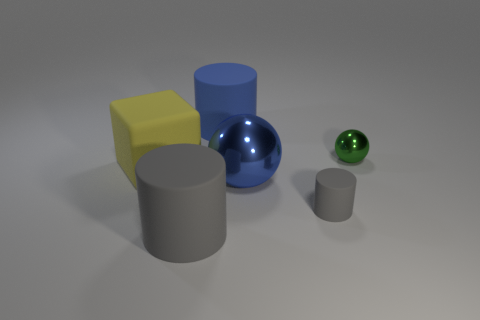There is a gray rubber object behind the big gray matte thing; what is its shape?
Offer a terse response. Cylinder. What number of big gray metal objects are there?
Ensure brevity in your answer.  0. Are the small green object and the blue sphere made of the same material?
Give a very brief answer. Yes. Are there more big blue rubber cylinders that are to the right of the large blue matte object than large yellow rubber cubes?
Your answer should be compact. No. How many objects are either blue spheres or large blue objects behind the big yellow object?
Keep it short and to the point. 2. Are there more blue matte cylinders that are to the left of the large yellow cube than green metallic objects in front of the blue ball?
Offer a terse response. No. There is a cylinder that is behind the gray matte object on the right side of the rubber object that is behind the yellow rubber thing; what is its material?
Keep it short and to the point. Rubber. What shape is the tiny thing that is made of the same material as the blue ball?
Give a very brief answer. Sphere. Are there any big yellow rubber things in front of the big yellow cube that is left of the small metallic thing?
Give a very brief answer. No. The blue ball is what size?
Offer a very short reply. Large. 